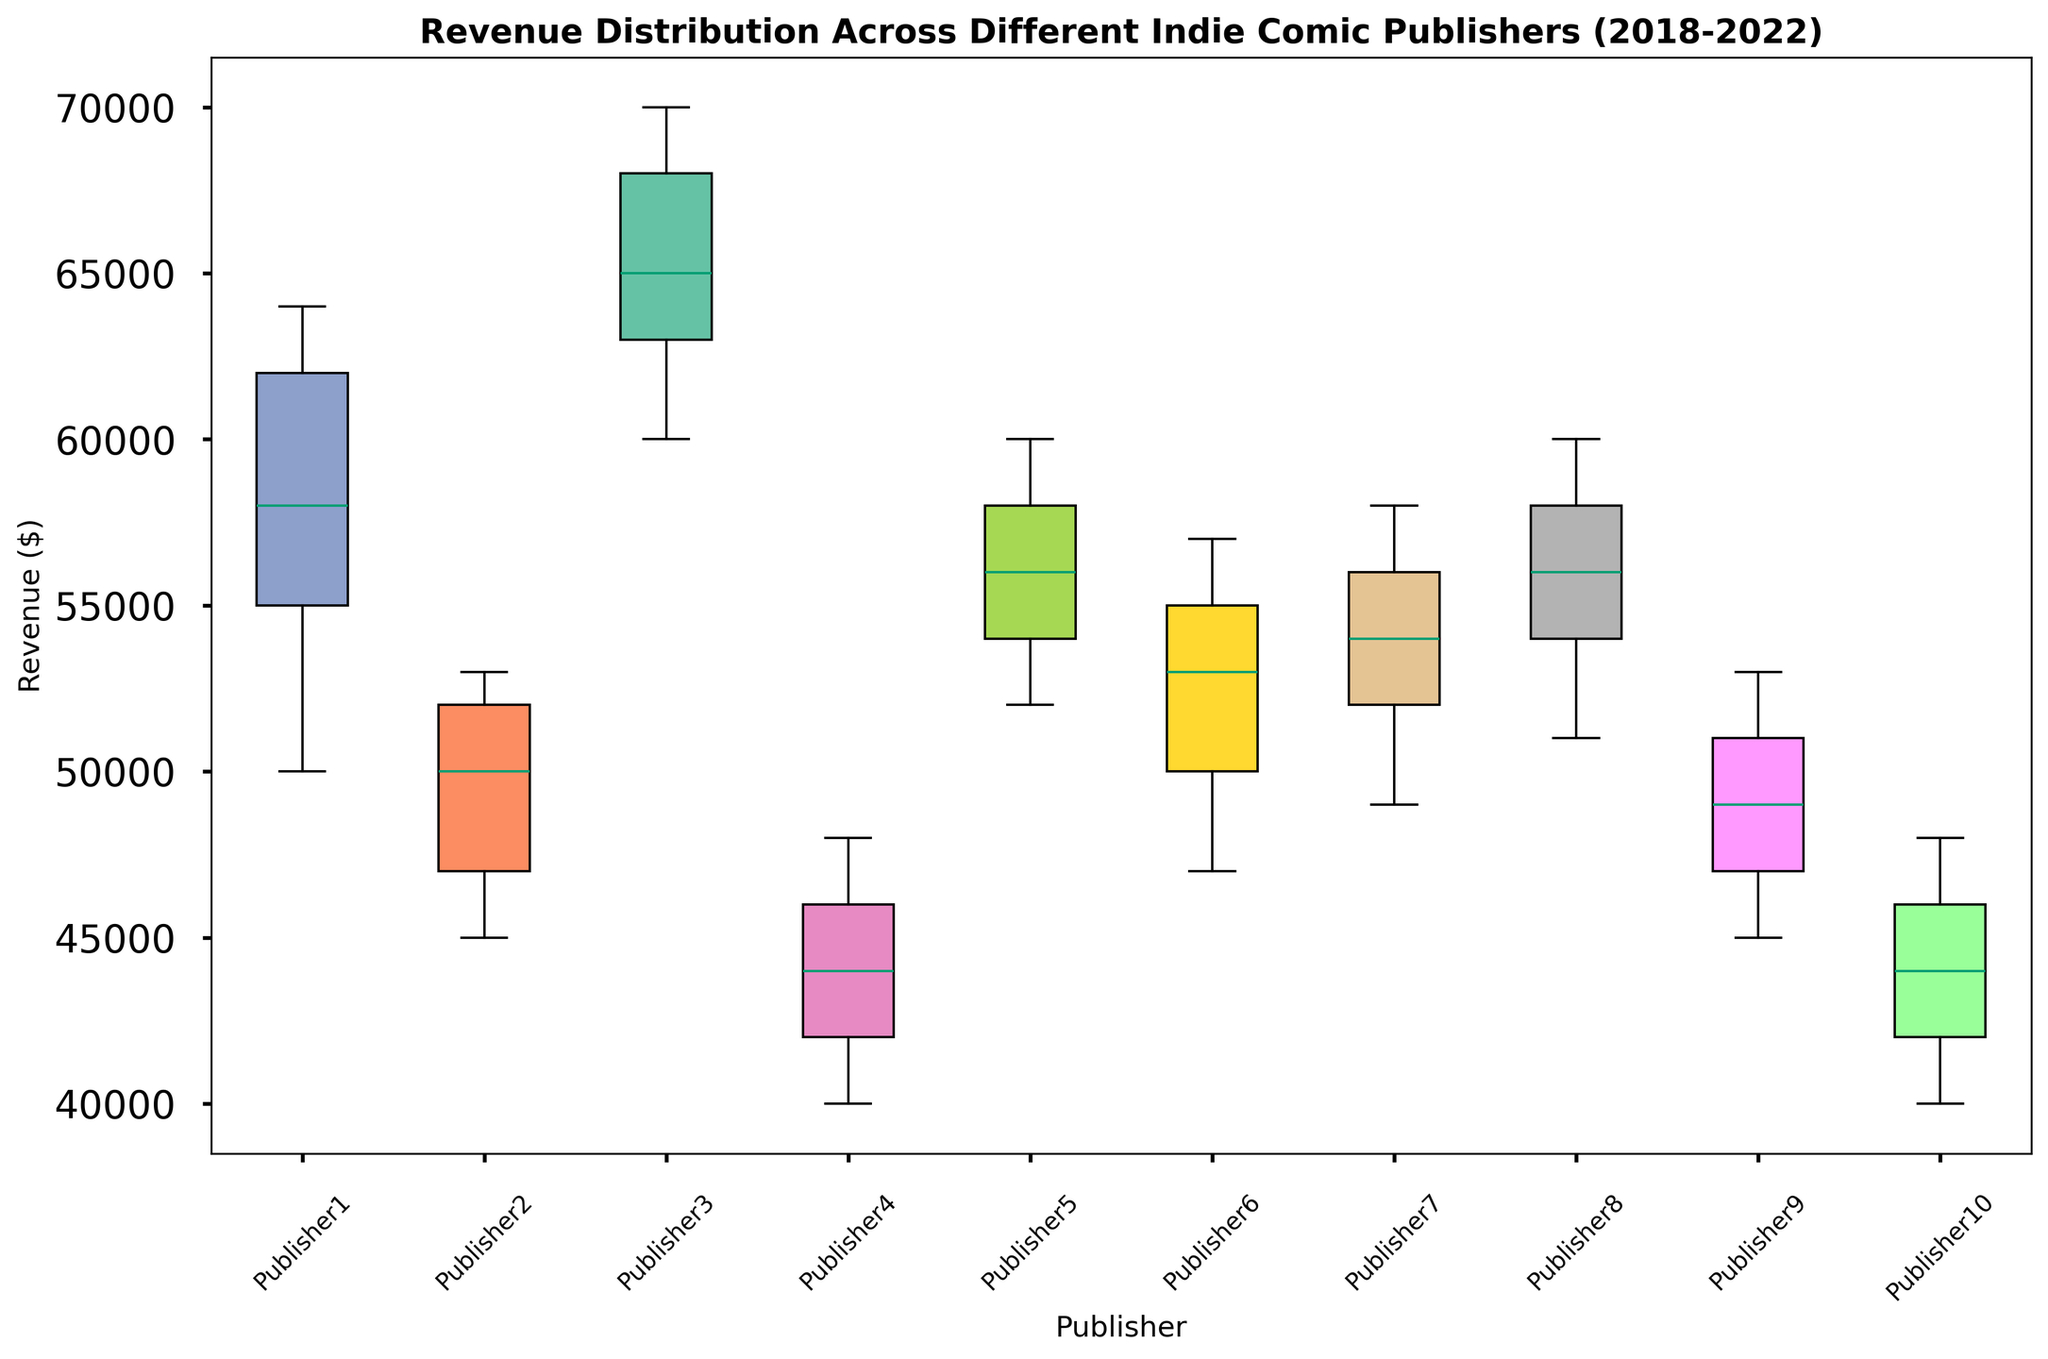What is the median revenue for Publisher1? Find Publisher1's revenue values: [50000, 55000, 58000, 62000, 64000]. The median is the middle value when arranged in ascending order, which is 58000.
Answer: 58000 Which publisher has the highest median revenue? Compare the median revenue of all publishers. Publisher3 has revenue values [60000, 63000, 65000, 68000, 70000], with a median of 65000. This is higher than the medians of other publishers.
Answer: Publisher3 Which publisher shows the smallest interquartile range (IQR)? Calculate the IQR for each publisher (75th percentile - 25th percentile). Publisher4 has revenue values [40000, 42000, 44000, 46000, 48000]. The IQR is the difference between 46000 (75th percentile) and 42000 (25th percentile): IQR = 46000 - 42000 = 4000. This is the smallest compared to other publishers.
Answer: Publisher4 What is the range of the revenue for Publisher2? Find Publisher2’s minimum and maximum revenue: [45000, 47000, 50000, 52000, 53000]. The range is max minus min: 53000 - 45000 = 8000.
Answer: 8000 Which publisher's box plot has the widest box? Examine the box widths for all publishers. Publisher1's box seems wider with revenue values spanning from about 54000 (Q1) to 62000 (Q3). So, the width (IQR) is about 62000 - 54000 = 8000.
Answer: Publisher1 Is there any outlier in the data? Check the box plots for any points that fall outside the whiskers. None of the box plots have points outside the whiskers, indicating no outliers.
Answer: No Which publisher's revenue has increased the most from 2018 to 2022? Compare the revenue changes for each publisher from 2018 to 2022. Publisher3 has increased from 60000 in 2018 to 70000 in 2022, an increase of 10000, which is the highest among all publishers.
Answer: Publisher3 Which publisher has a more consistent (less variable) revenue over the years? Look at the spread of data (IQR and range) for consistency. Publisher4 has a narrow spread of 4000 (IQR) and a small range from 40000 to 48000, indicating more consistency.
Answer: Publisher4 